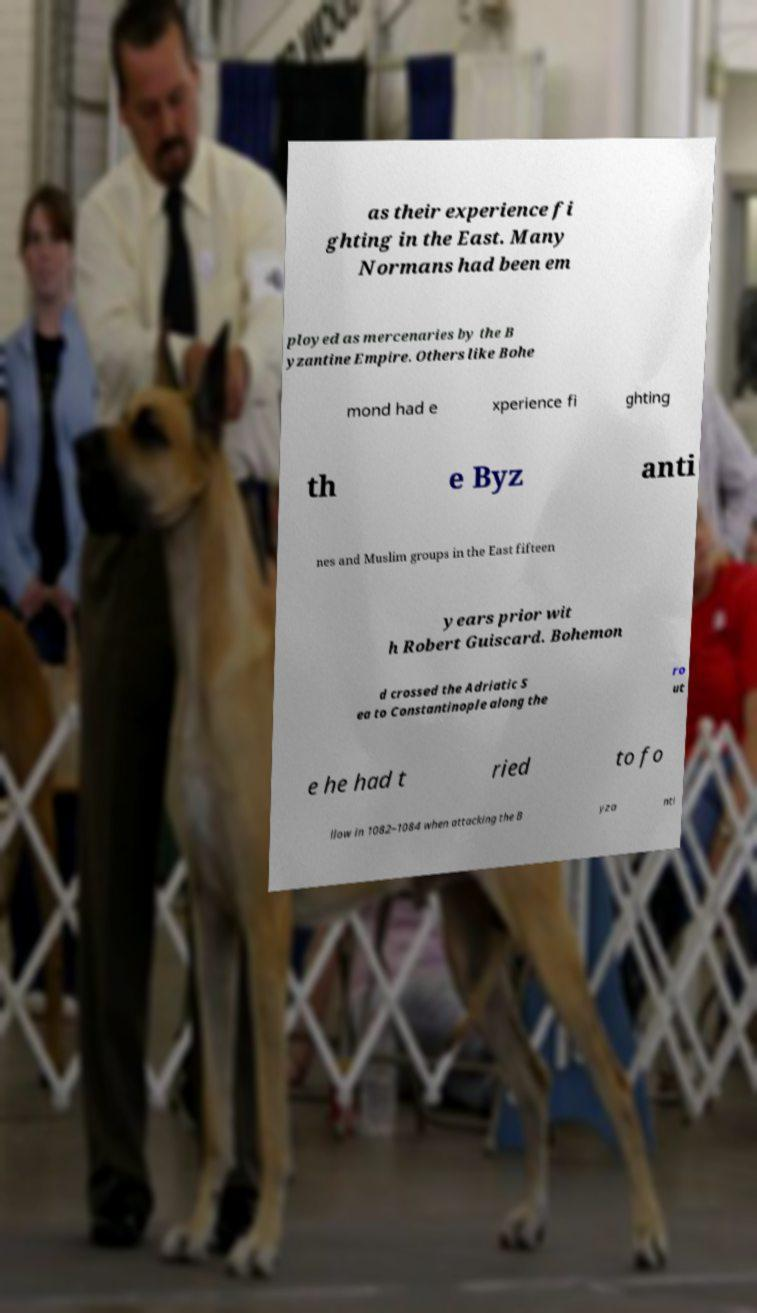Could you assist in decoding the text presented in this image and type it out clearly? as their experience fi ghting in the East. Many Normans had been em ployed as mercenaries by the B yzantine Empire. Others like Bohe mond had e xperience fi ghting th e Byz anti nes and Muslim groups in the East fifteen years prior wit h Robert Guiscard. Bohemon d crossed the Adriatic S ea to Constantinople along the ro ut e he had t ried to fo llow in 1082–1084 when attacking the B yza nti 